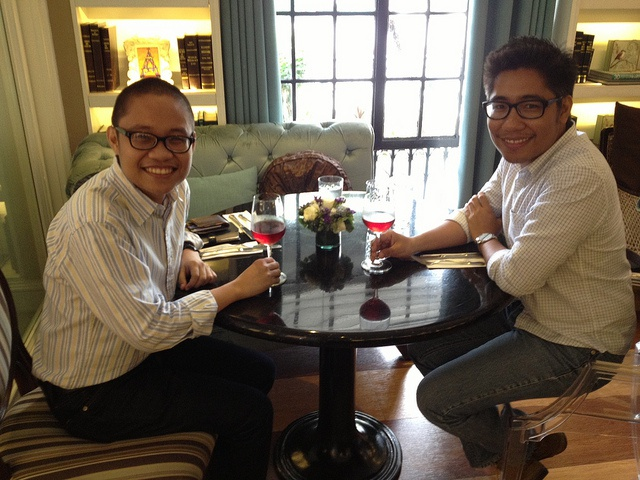Describe the objects in this image and their specific colors. I can see people in olive, black, gray, and tan tones, people in olive, black, and gray tones, dining table in olive, black, gray, darkgray, and white tones, couch in olive and gray tones, and chair in olive, black, maroon, and gray tones in this image. 